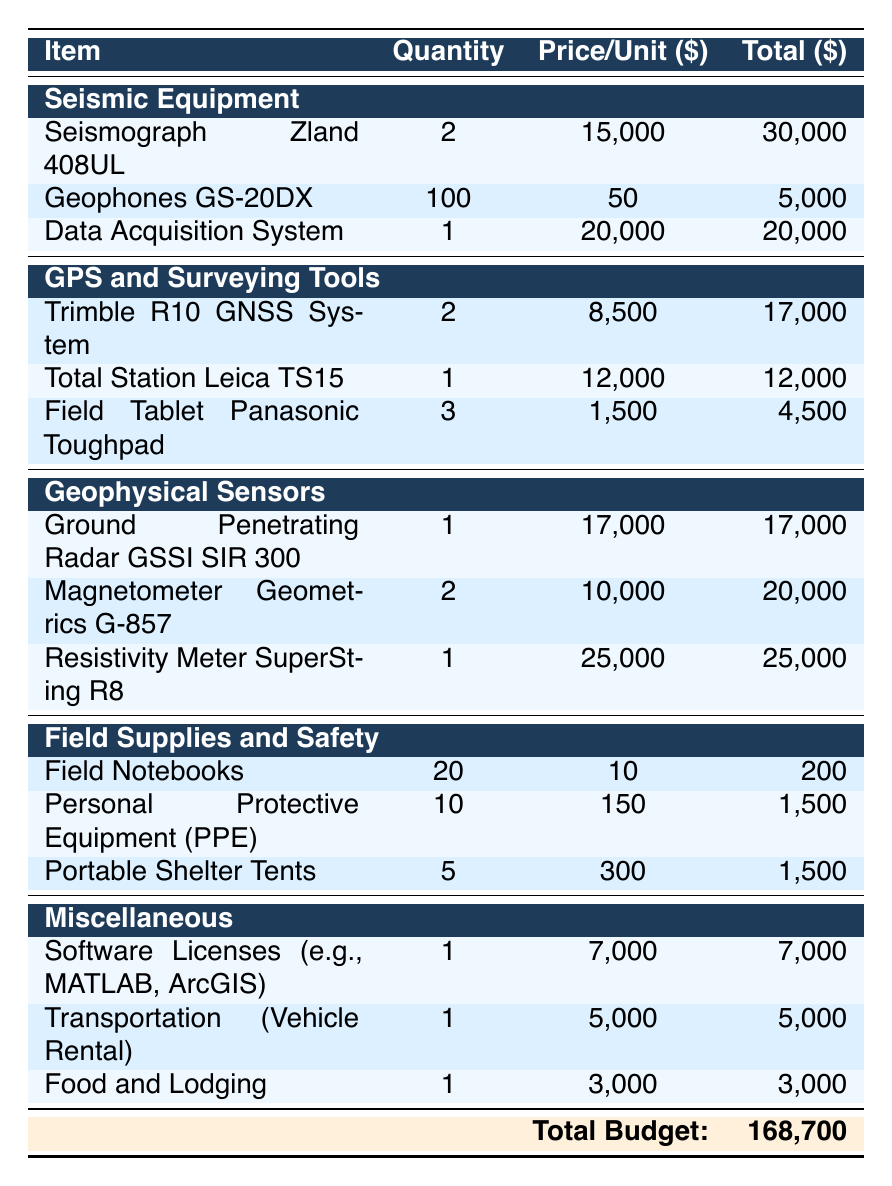What is the total cost of Seismic Equipment? In the Seismic Equipment category, the total costs are: Seismograph Zland 408UL (30,000) + Geophones GS-20DX (5,000) + Data Acquisition System (20,000). Adding these together gives: 30,000 + 5,000 + 20,000 = 55,000.
Answer: 55,000 How many items are listed under GPS and Surveying Tools? Under the GPS and Surveying Tools category, there are three items: Trimble R10 GNSS System, Total Station Leica TS15, and Field Tablet Panasonic Toughpad. Therefore, the total number of items is 3.
Answer: 3 Is the price per unit of the Ground Penetrating Radar higher than the Resistivity Meter? The price per unit for Ground Penetrating Radar GSSI SIR 300 is 17,000 and for the Resistivity Meter SuperSting R8 is 25,000. Since 17,000 is less than 25,000, the statement is false.
Answer: No What is the average cost of items listed under Field Supplies and Safety? The total costs for Field Supplies and Safety items are: Field Notebooks (200) + Personal Protective Equipment (1,500) + Portable Shelter Tents (1,500). The sum is 200 + 1,500 + 1,500 = 3,200. There are 3 items, so the average cost is 3,200 / 3 = 1,066.67.
Answer: 1,066.67 What is the total budget for all categories? The table indicates the total budget at the bottom, which is explicitly stated as 168,700. This value represents the combined costs of all categories.
Answer: 168,700 Which category has the highest total cost? Analyzing the total costs for each category: Seismic Equipment (55,000), GPS and Surveying Tools (33,500), Geophysical Sensors (62,000), Field Supplies and Safety (3,200), and Miscellaneous (15,000). The highest category is Geophysical Sensors with a total cost of 62,000.
Answer: Geophysical Sensors Does the expense for Food and Lodging exceed the combined cost of Field Notebooks and Personal Protective Equipment? The cost of Food and Lodging is 3,000, while the combined cost for Field Notebooks (200) and Personal Protective Equipment (1,500) is 200 + 1,500 = 1,700. Since 3,000 is greater than 1,700, the statement is true.
Answer: Yes How much more is spent on the Data Acquisition System than one Geophone? The cost of the Data Acquisition System is 20,000, and the price of one Geophone GS-20DX is 50. The difference is 20,000 - 50 = 19,950.
Answer: 19,950 How much does Personal Protective Equipment cost in total? There are 10 items of Personal Protective Equipment purchased at a price of 150 each. Therefore, the total cost is 10 * 150 = 1,500.
Answer: 1,500 